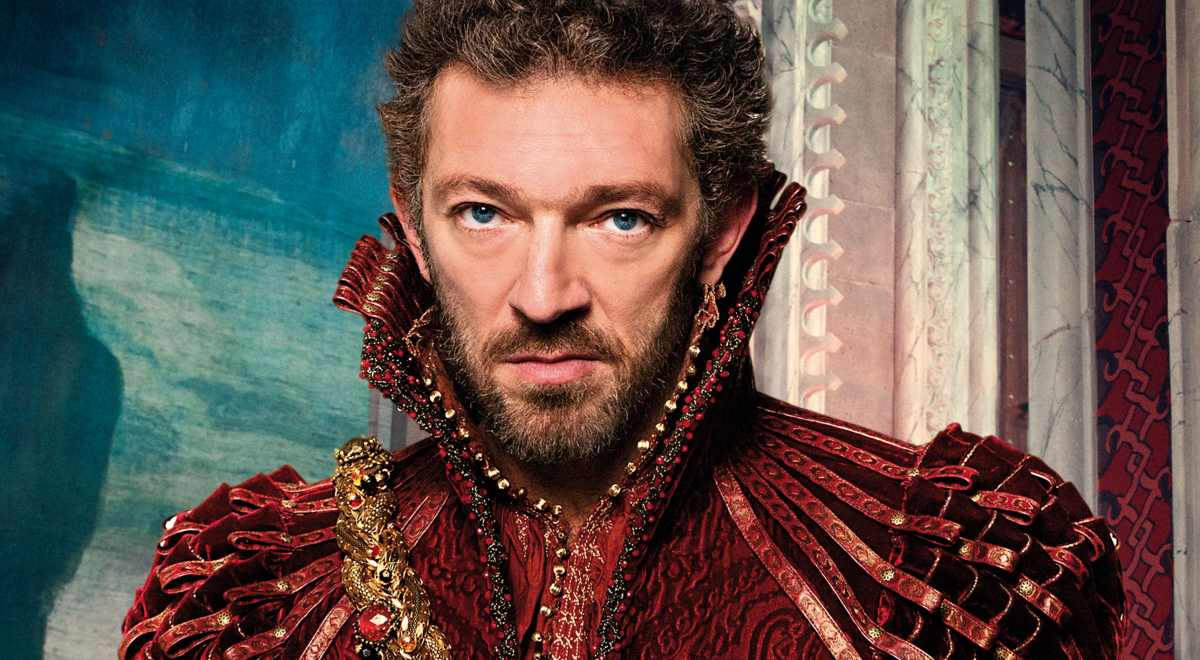Can you provide some historical context or inspiration for such an elaborate costume? The elaborate costume seen in the image appears to draw inspiration from the attire worn by European nobility during the Renaissance era. This period was marked by opulent clothing adorned with luxurious fabrics like silk and velvet, intricate embroidery, and elaborate jewelry. The high collar and rich embellishments are characteristic of the fashion styles that were popular among royalty and high-ranking officials of that time. 